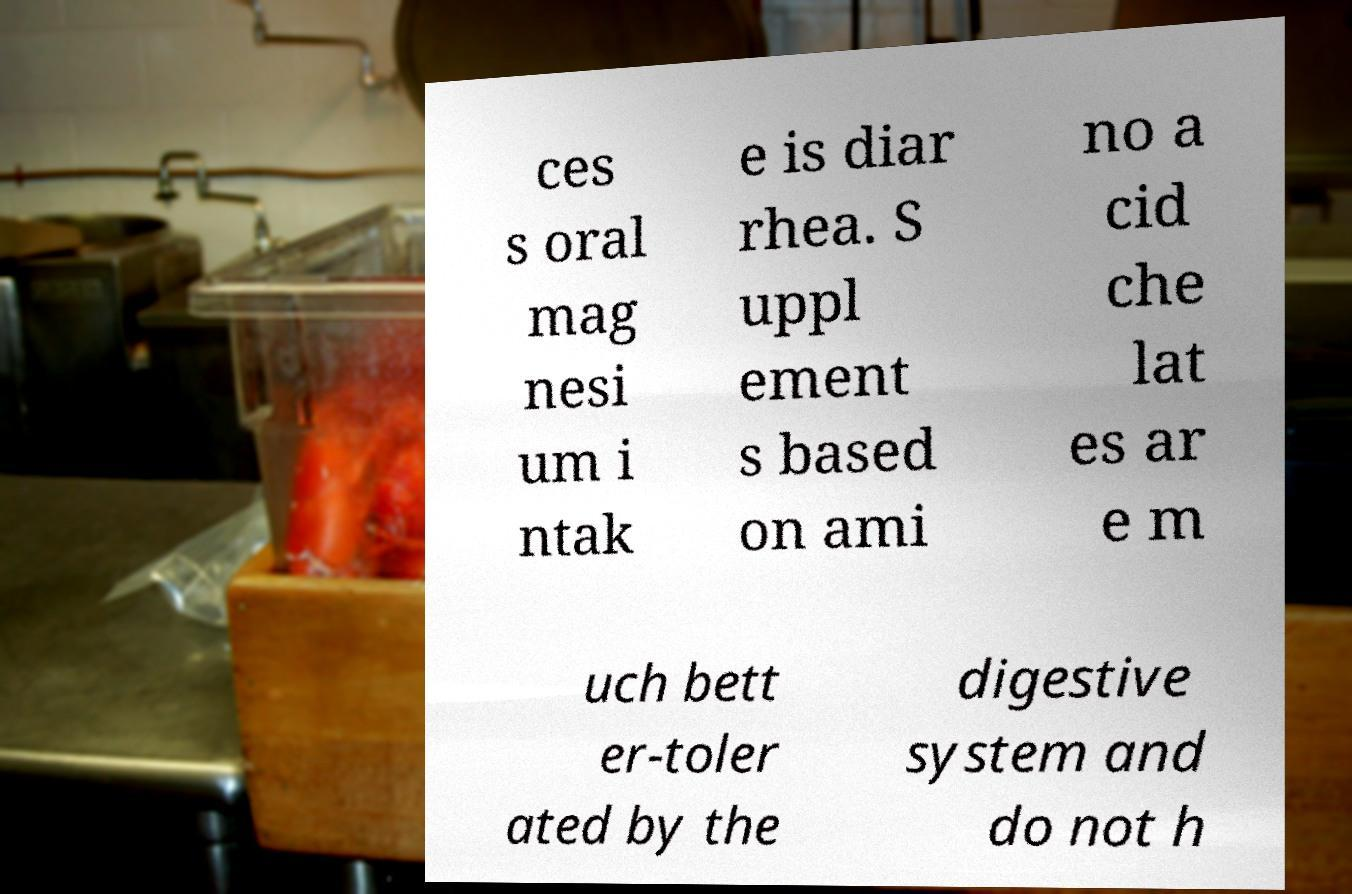Can you read and provide the text displayed in the image?This photo seems to have some interesting text. Can you extract and type it out for me? ces s oral mag nesi um i ntak e is diar rhea. S uppl ement s based on ami no a cid che lat es ar e m uch bett er-toler ated by the digestive system and do not h 